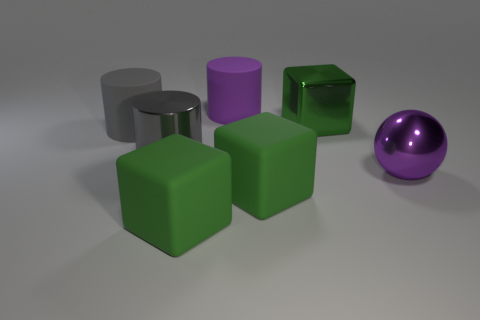How many green blocks must be subtracted to get 1 green blocks? 2 Subtract all metal cubes. How many cubes are left? 2 Subtract all gray cylinders. How many cylinders are left? 1 Subtract all balls. How many objects are left? 6 Subtract 2 cylinders. How many cylinders are left? 1 Subtract all blocks. Subtract all gray metal cylinders. How many objects are left? 3 Add 6 gray shiny cylinders. How many gray shiny cylinders are left? 7 Add 4 tiny yellow matte spheres. How many tiny yellow matte spheres exist? 4 Add 1 large blocks. How many objects exist? 8 Subtract 0 red spheres. How many objects are left? 7 